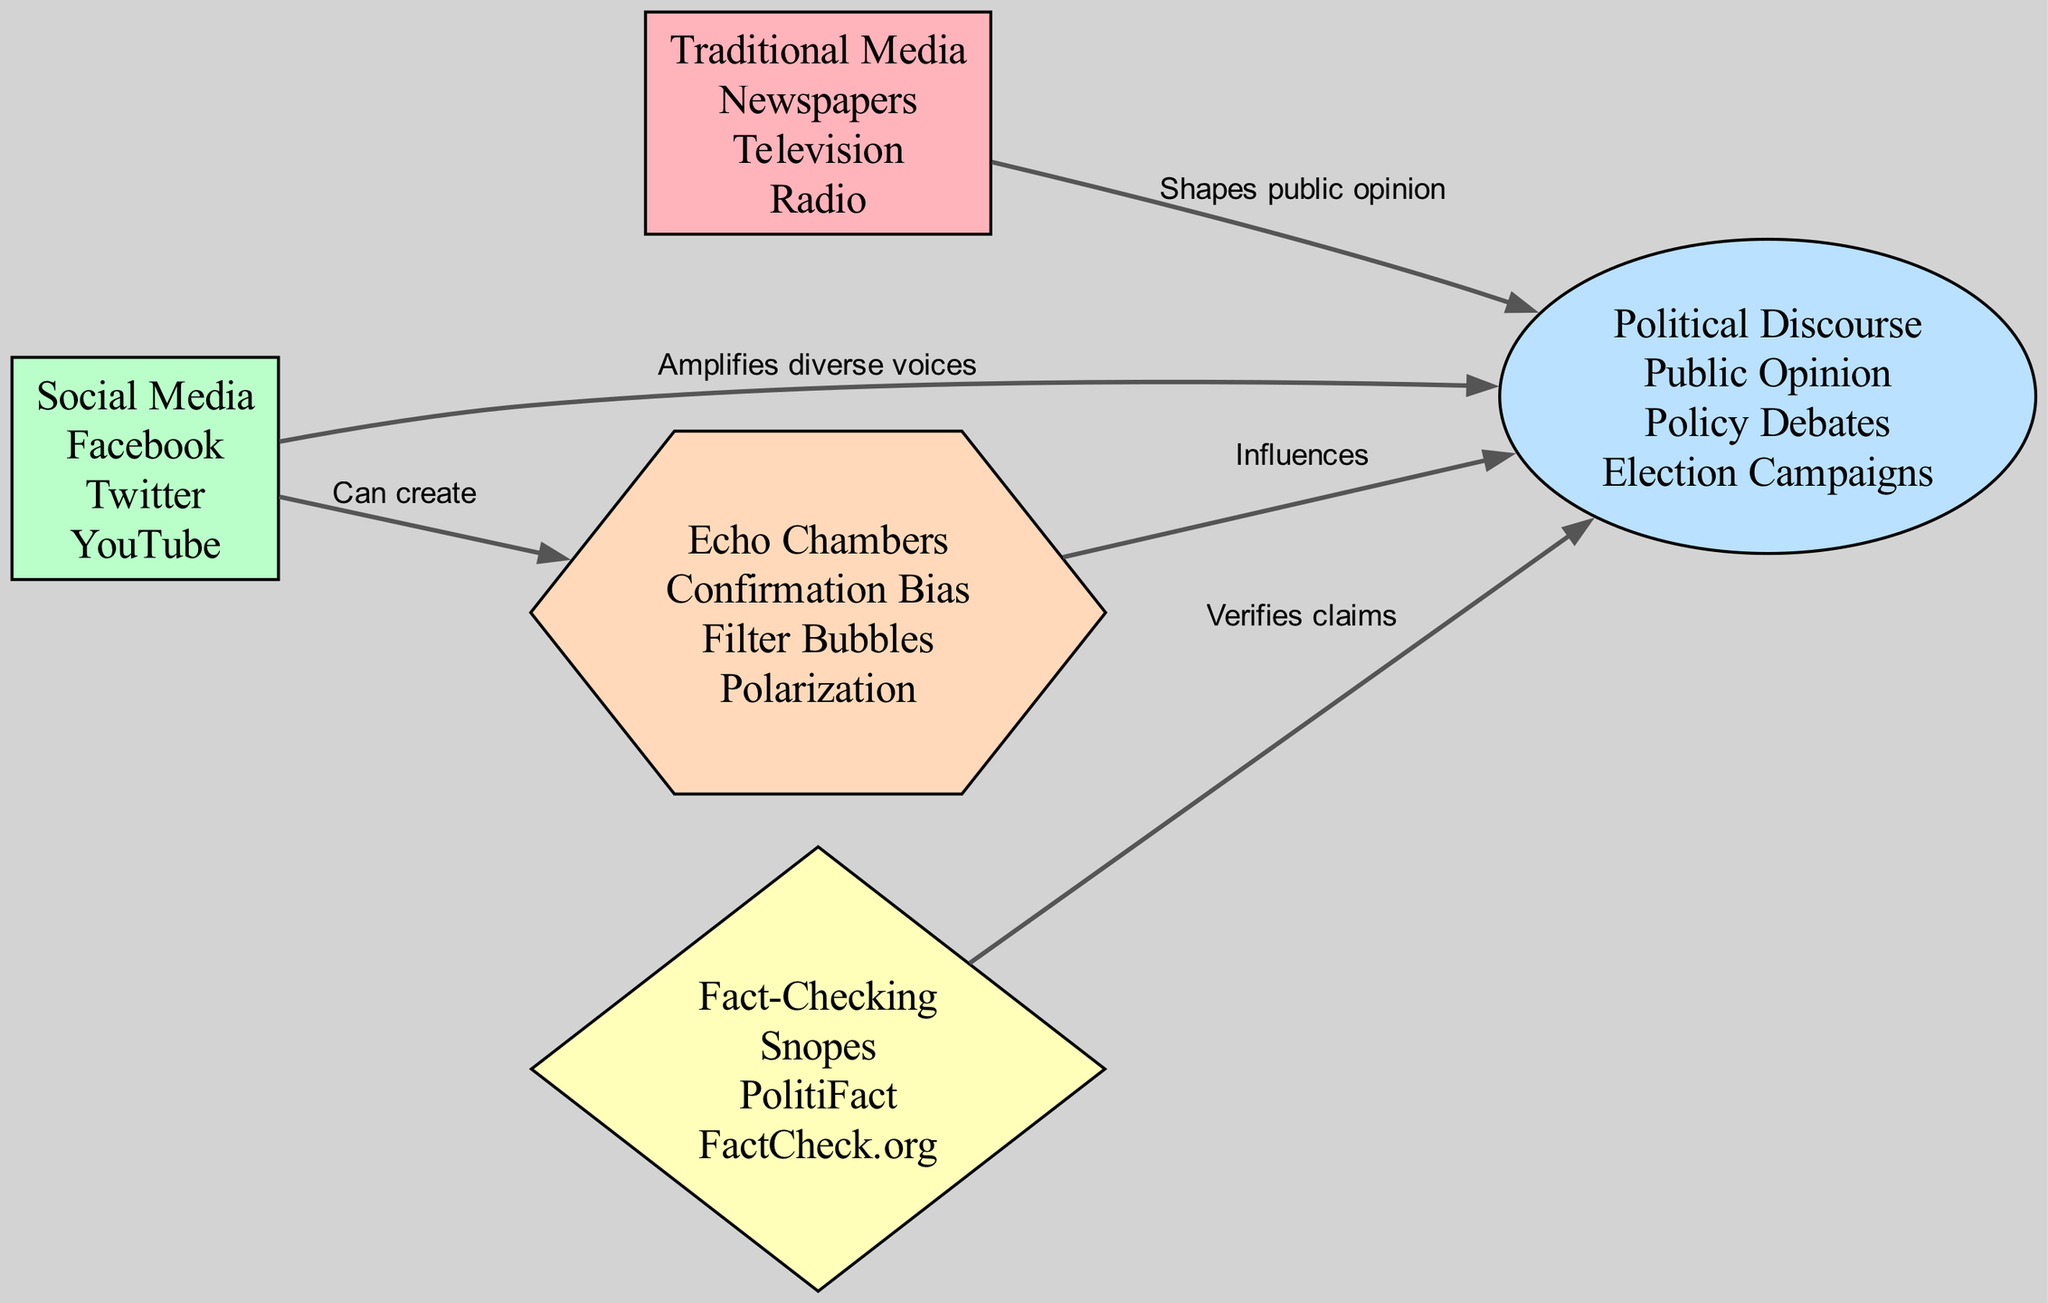What are the three elements of Traditional Media? The diagram indicates that Traditional Media includes Newspapers, Television, and Radio. This information is found in the node labeled "Traditional Media."
Answer: Newspapers, Television, Radio How many edges are present in the diagram? By examining the edges listed in the diagram, there are a total of five connections between nodes. Thus, the number of edges is counted directly from the listed connections.
Answer: 5 What does Traditional Media do to Political Discourse? The connection from Traditional Media to Political Discourse is labeled "Shapes public opinion." This describes the role of Traditional Media in influencing Political Discourse indicated in the diagram.
Answer: Shapes public opinion Which platform is said to amplify diverse voices? The arrow from Social Media to Political Discourse is labeled "Amplifies diverse voices," highlighting the specific role Social Media plays in enhancing political discussions.
Answer: Social Media What does Fact-Checking do in relation to Political Discourse? The diagram shows an edge from Fact-Checking to Political Discourse labeled "Verifies claims." This connection indicates the function of Fact-Checking within the context of Political Discourse.
Answer: Verifies claims How does Social Media influence Echo Chambers? The diagram indicates that Social Media can create Echo Chambers. This relationship is shown by the edge from Social Media to Echo Chambers with the label "Can create."
Answer: Can create What influences Political Discourse by causing polarization? The edge from Echo Chambers to Political Discourse is labeled "Influences," which shows that Echo Chambers contribute to how polarization affects Political Discourse.
Answer: Influences 